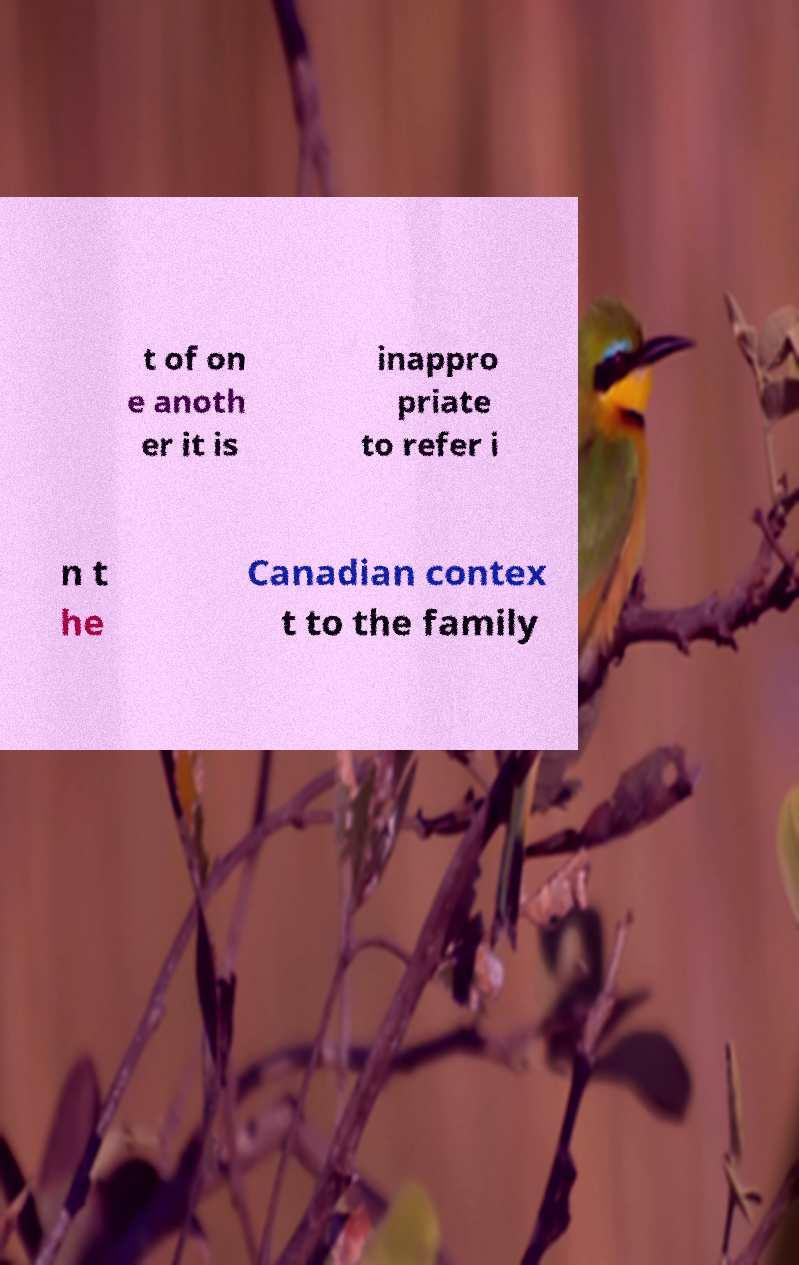There's text embedded in this image that I need extracted. Can you transcribe it verbatim? t of on e anoth er it is inappro priate to refer i n t he Canadian contex t to the family 